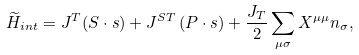<formula> <loc_0><loc_0><loc_500><loc_500>\widetilde { H } _ { i n t } = J ^ { T } ( { S \cdot s } ) + J ^ { S T } \left ( { P } \cdot { s } \right ) + \frac { J _ { T } } { 2 } \sum _ { \mu \sigma } X ^ { \mu \mu } n _ { \sigma } ,</formula> 